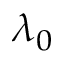Convert formula to latex. <formula><loc_0><loc_0><loc_500><loc_500>\lambda _ { 0 }</formula> 